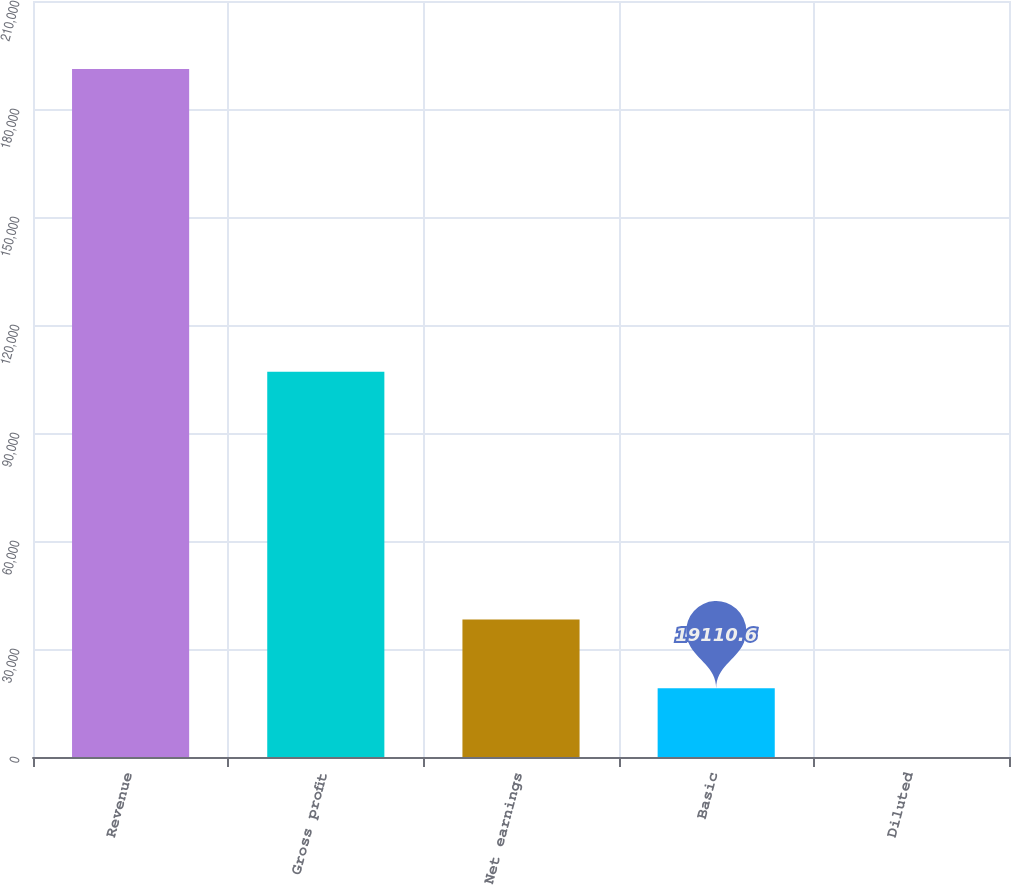Convert chart to OTSL. <chart><loc_0><loc_0><loc_500><loc_500><bar_chart><fcel>Revenue<fcel>Gross profit<fcel>Net earnings<fcel>Basic<fcel>Diluted<nl><fcel>191104<fcel>107023<fcel>38221<fcel>19110.6<fcel>0.22<nl></chart> 